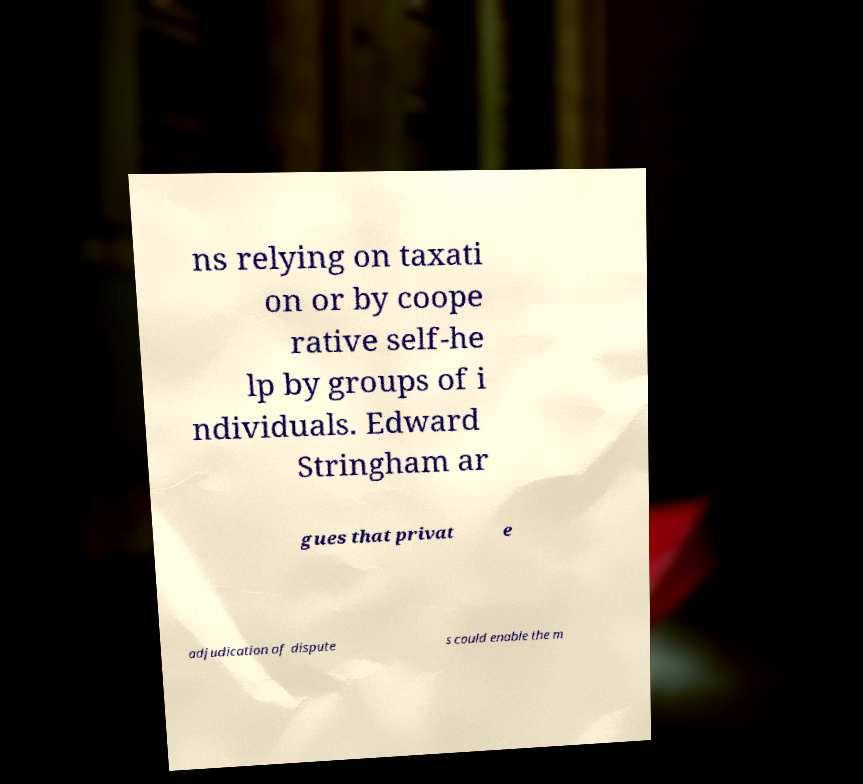What messages or text are displayed in this image? I need them in a readable, typed format. ns relying on taxati on or by coope rative self-he lp by groups of i ndividuals. Edward Stringham ar gues that privat e adjudication of dispute s could enable the m 